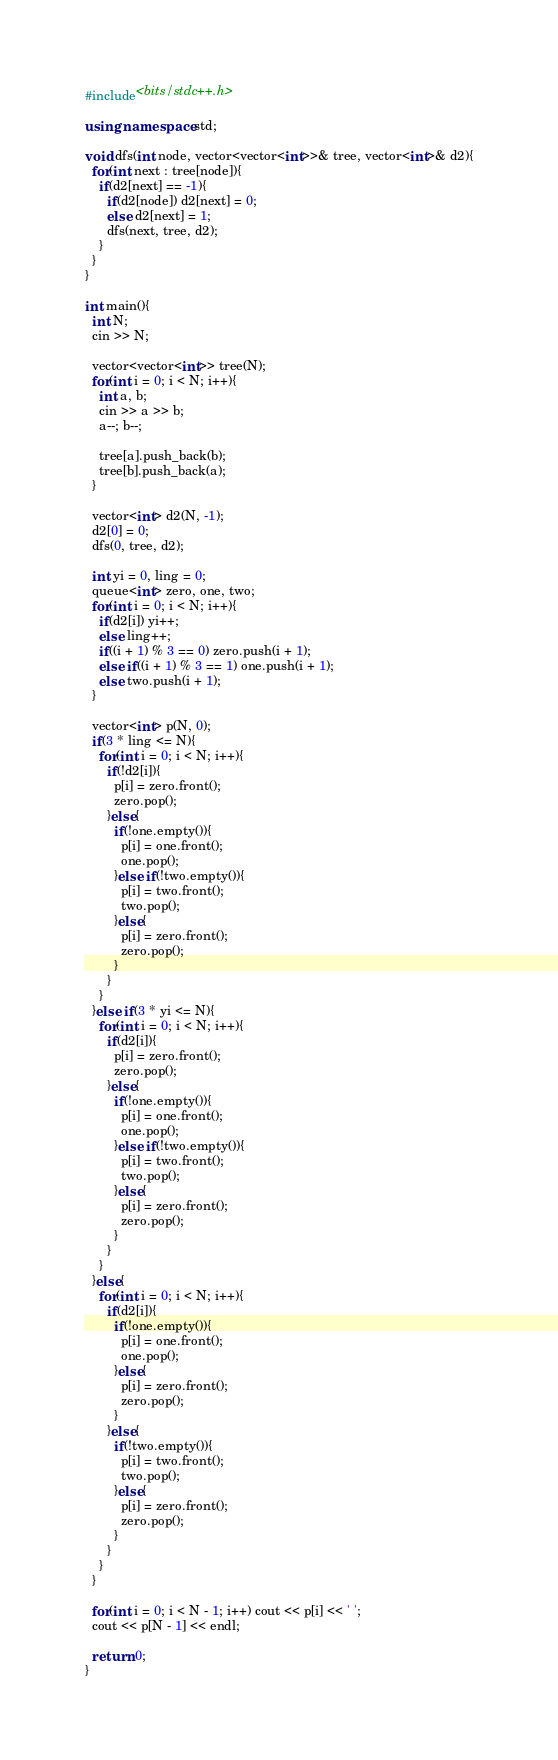Convert code to text. <code><loc_0><loc_0><loc_500><loc_500><_C++_>#include<bits/stdc++.h>

using namespace std;

void dfs(int node, vector<vector<int>>& tree, vector<int>& d2){
  for(int next : tree[node]){
    if(d2[next] == -1){
      if(d2[node]) d2[next] = 0;
      else d2[next] = 1;
      dfs(next, tree, d2);
    }
  }
}

int main(){
  int N;
  cin >> N;
  
  vector<vector<int>> tree(N);
  for(int i = 0; i < N; i++){
    int a, b;
    cin >> a >> b;
    a--; b--;
    
    tree[a].push_back(b);
    tree[b].push_back(a);
  }
  
  vector<int> d2(N, -1);
  d2[0] = 0;
  dfs(0, tree, d2);
  
  int yi = 0, ling = 0;
  queue<int> zero, one, two;
  for(int i = 0; i < N; i++){
    if(d2[i]) yi++;
    else ling++;
    if((i + 1) % 3 == 0) zero.push(i + 1);
    else if((i + 1) % 3 == 1) one.push(i + 1);
    else two.push(i + 1);
  }
  
  vector<int> p(N, 0);
  if(3 * ling <= N){
    for(int i = 0; i < N; i++){
      if(!d2[i]){
        p[i] = zero.front();
        zero.pop();
      }else{
        if(!one.empty()){
          p[i] = one.front();
          one.pop();
        }else if(!two.empty()){
          p[i] = two.front();
          two.pop();
        }else{
          p[i] = zero.front();
          zero.pop();
        }
      }
    }
  }else if(3 * yi <= N){
    for(int i = 0; i < N; i++){
      if(d2[i]){
        p[i] = zero.front();
        zero.pop();
      }else{
        if(!one.empty()){
          p[i] = one.front();
          one.pop();
        }else if(!two.empty()){
          p[i] = two.front();
          two.pop();
        }else{
          p[i] = zero.front();
          zero.pop();
        }
      }
    }
  }else{
    for(int i = 0; i < N; i++){
      if(d2[i]){
        if(!one.empty()){
          p[i] = one.front();
          one.pop();
        }else{
          p[i] = zero.front();
          zero.pop();
        }
      }else{
        if(!two.empty()){
          p[i] = two.front();
          two.pop();
        }else{
          p[i] = zero.front();
          zero.pop();
        }
      }
    }
  }
  
  for(int i = 0; i < N - 1; i++) cout << p[i] << ' ';
  cout << p[N - 1] << endl;
  
  return 0;
}</code> 